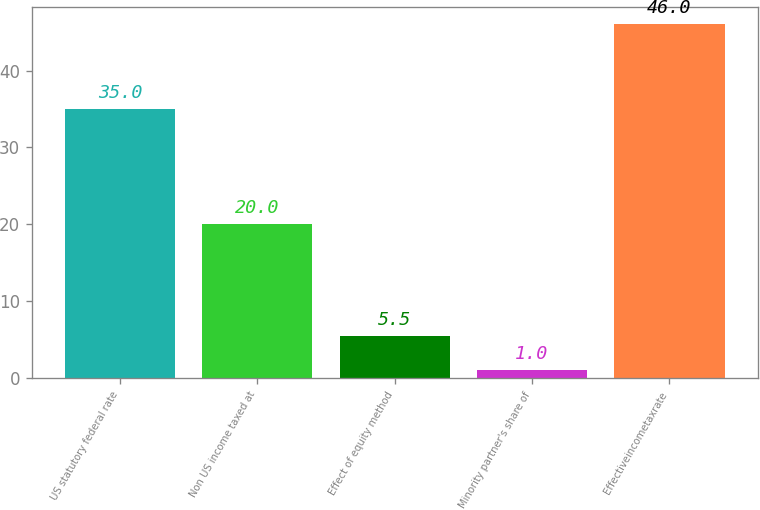Convert chart to OTSL. <chart><loc_0><loc_0><loc_500><loc_500><bar_chart><fcel>US statutory federal rate<fcel>Non US income taxed at<fcel>Effect of equity method<fcel>Minority partner's share of<fcel>Effectiveincometaxrate<nl><fcel>35<fcel>20<fcel>5.5<fcel>1<fcel>46<nl></chart> 